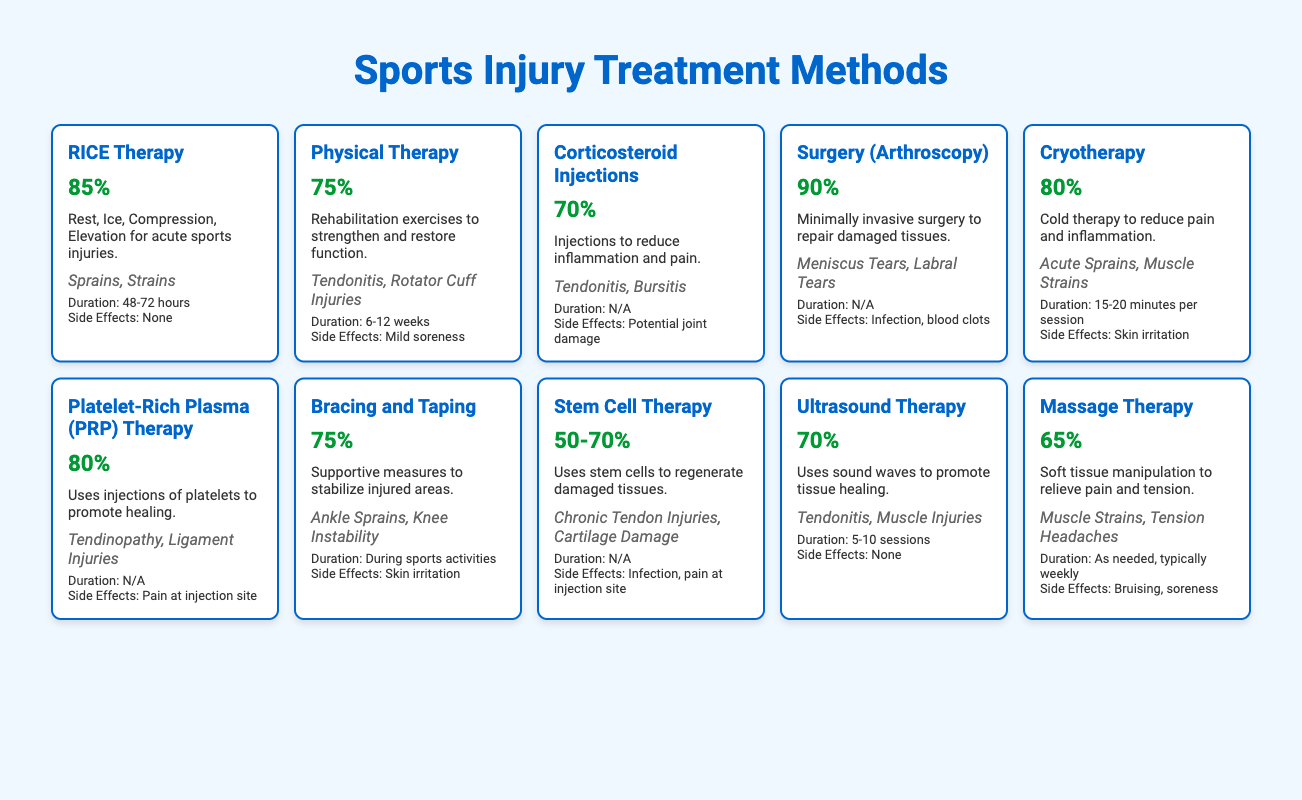What is the success rate of RICE Therapy? The success rate of RICE Therapy is directly listed in the table as 85%.
Answer: 85% Which treatment method has the highest success rate? By reviewing the success rates listed in the table, Surgery (Arthroscopy) has the highest success rate at 90%.
Answer: 90% How many treatment methods have a success rate of 75% or higher? There are six treatment methods with a success rate of 75% or higher: RICE Therapy (85%), Surgery (Arthroscopy) (90%), Cryotherapy (80%), Platelet-Rich Plasma (PRP) Therapy (80%), and Physical Therapy (75%).
Answer: 6 Is there a treatment method with a success rate of less than 60%? After checking all the success rates in the table, no treatment method lists a success rate of less than 60%.
Answer: No What is the average success rate of the treatments listed? To find the average, sum the success rates: (85 + 75 + 70 + 90 + 80 + 80 + 75 + 60 + 70 + 65) =  785. There are 10 methods, so the average is 785/10 = 78.5%.
Answer: 78.5% Which treatment methods have side effects? By looking through the side effects column, the treatments with noted side effects are: Corticosteroid Injections (potential joint damage), Surgery (Infection, blood clots), Cryotherapy (skin irritation), Platelet-Rich Plasma (pain at injection site), Bracing and Taping (skin irritation), Stem Cell Therapy (infection, pain at injection site), and Massage Therapy (bruising, soreness).
Answer: 7 How long does Physical Therapy typically last? The recommended duration for Physical Therapy is specified in the table as 6-12 weeks.
Answer: 6-12 weeks Which treatment is recommended for acute sprains? The treatment method recommended for acute sprains according to the typical injuries listed is RICE Therapy.
Answer: RICE Therapy What is the minimum success rate among the treatments that involve injections? From the table, the treatments involving injections are Corticosteroid Injections, Stem Cell Therapy, and Platelet-Rich Plasma (PRP) Therapy, with success rates of 70%, 50-70%, and 80%, respectively. The minimum success rate here is 50%.
Answer: 50% 